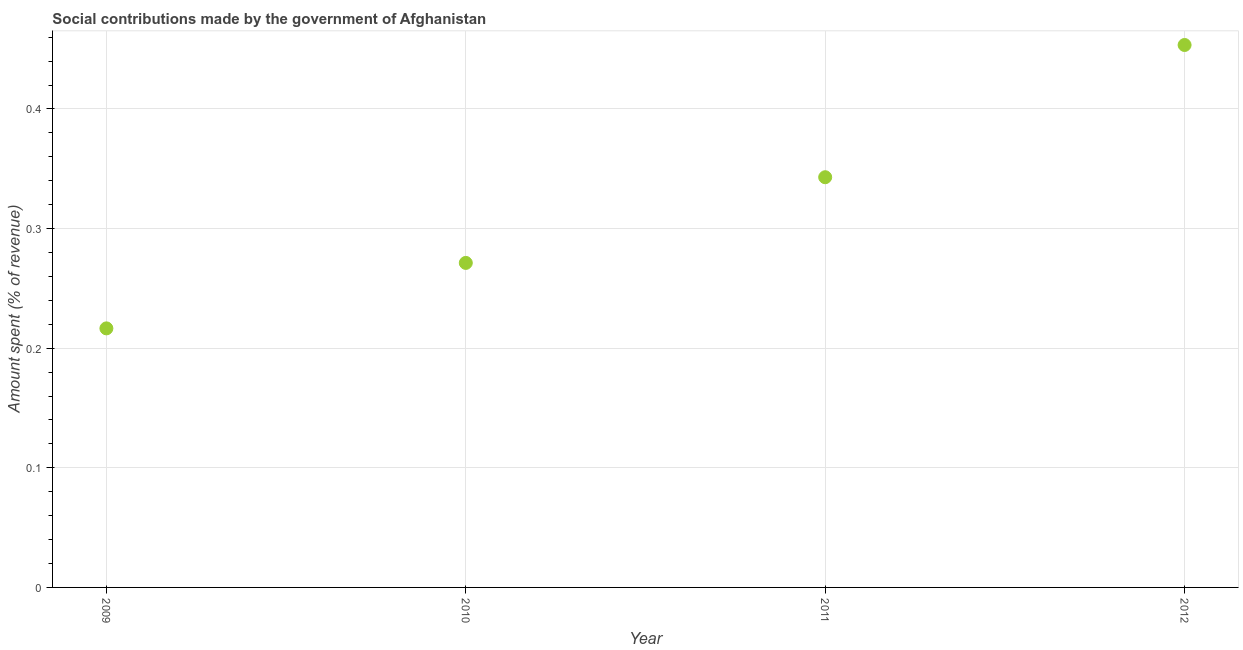What is the amount spent in making social contributions in 2010?
Provide a succinct answer. 0.27. Across all years, what is the maximum amount spent in making social contributions?
Your answer should be compact. 0.45. Across all years, what is the minimum amount spent in making social contributions?
Your answer should be very brief. 0.22. In which year was the amount spent in making social contributions maximum?
Provide a succinct answer. 2012. In which year was the amount spent in making social contributions minimum?
Offer a very short reply. 2009. What is the sum of the amount spent in making social contributions?
Your answer should be very brief. 1.28. What is the difference between the amount spent in making social contributions in 2009 and 2012?
Your response must be concise. -0.24. What is the average amount spent in making social contributions per year?
Ensure brevity in your answer.  0.32. What is the median amount spent in making social contributions?
Provide a succinct answer. 0.31. In how many years, is the amount spent in making social contributions greater than 0.4 %?
Your response must be concise. 1. Do a majority of the years between 2011 and 2012 (inclusive) have amount spent in making social contributions greater than 0.04 %?
Provide a succinct answer. Yes. What is the ratio of the amount spent in making social contributions in 2009 to that in 2010?
Provide a succinct answer. 0.8. Is the difference between the amount spent in making social contributions in 2010 and 2012 greater than the difference between any two years?
Offer a terse response. No. What is the difference between the highest and the second highest amount spent in making social contributions?
Keep it short and to the point. 0.11. What is the difference between the highest and the lowest amount spent in making social contributions?
Your answer should be compact. 0.24. How many dotlines are there?
Your answer should be compact. 1. How many years are there in the graph?
Your response must be concise. 4. What is the difference between two consecutive major ticks on the Y-axis?
Give a very brief answer. 0.1. Does the graph contain grids?
Your answer should be very brief. Yes. What is the title of the graph?
Your response must be concise. Social contributions made by the government of Afghanistan. What is the label or title of the Y-axis?
Give a very brief answer. Amount spent (% of revenue). What is the Amount spent (% of revenue) in 2009?
Provide a succinct answer. 0.22. What is the Amount spent (% of revenue) in 2010?
Your response must be concise. 0.27. What is the Amount spent (% of revenue) in 2011?
Keep it short and to the point. 0.34. What is the Amount spent (% of revenue) in 2012?
Offer a terse response. 0.45. What is the difference between the Amount spent (% of revenue) in 2009 and 2010?
Give a very brief answer. -0.05. What is the difference between the Amount spent (% of revenue) in 2009 and 2011?
Give a very brief answer. -0.13. What is the difference between the Amount spent (% of revenue) in 2009 and 2012?
Provide a short and direct response. -0.24. What is the difference between the Amount spent (% of revenue) in 2010 and 2011?
Offer a very short reply. -0.07. What is the difference between the Amount spent (% of revenue) in 2010 and 2012?
Offer a very short reply. -0.18. What is the difference between the Amount spent (% of revenue) in 2011 and 2012?
Give a very brief answer. -0.11. What is the ratio of the Amount spent (% of revenue) in 2009 to that in 2010?
Your answer should be compact. 0.8. What is the ratio of the Amount spent (% of revenue) in 2009 to that in 2011?
Give a very brief answer. 0.63. What is the ratio of the Amount spent (% of revenue) in 2009 to that in 2012?
Provide a succinct answer. 0.48. What is the ratio of the Amount spent (% of revenue) in 2010 to that in 2011?
Make the answer very short. 0.79. What is the ratio of the Amount spent (% of revenue) in 2010 to that in 2012?
Make the answer very short. 0.6. What is the ratio of the Amount spent (% of revenue) in 2011 to that in 2012?
Your answer should be compact. 0.76. 